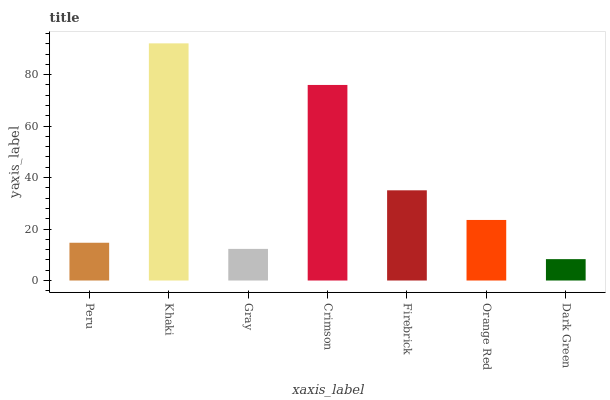Is Dark Green the minimum?
Answer yes or no. Yes. Is Khaki the maximum?
Answer yes or no. Yes. Is Gray the minimum?
Answer yes or no. No. Is Gray the maximum?
Answer yes or no. No. Is Khaki greater than Gray?
Answer yes or no. Yes. Is Gray less than Khaki?
Answer yes or no. Yes. Is Gray greater than Khaki?
Answer yes or no. No. Is Khaki less than Gray?
Answer yes or no. No. Is Orange Red the high median?
Answer yes or no. Yes. Is Orange Red the low median?
Answer yes or no. Yes. Is Dark Green the high median?
Answer yes or no. No. Is Gray the low median?
Answer yes or no. No. 